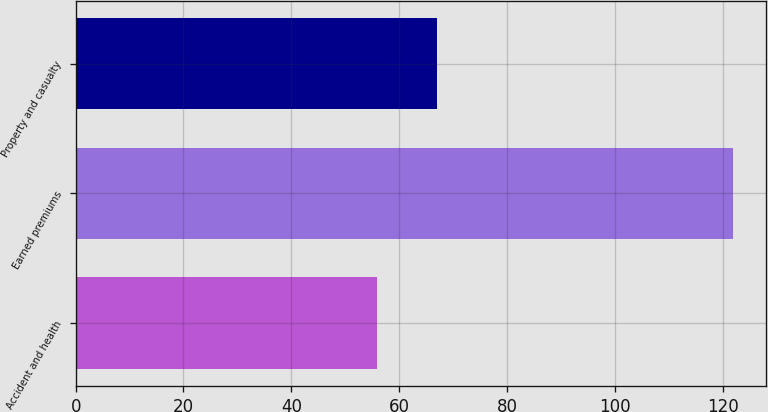<chart> <loc_0><loc_0><loc_500><loc_500><bar_chart><fcel>Accident and health<fcel>Earned premiums<fcel>Property and casualty<nl><fcel>55.9<fcel>121.9<fcel>67<nl></chart> 